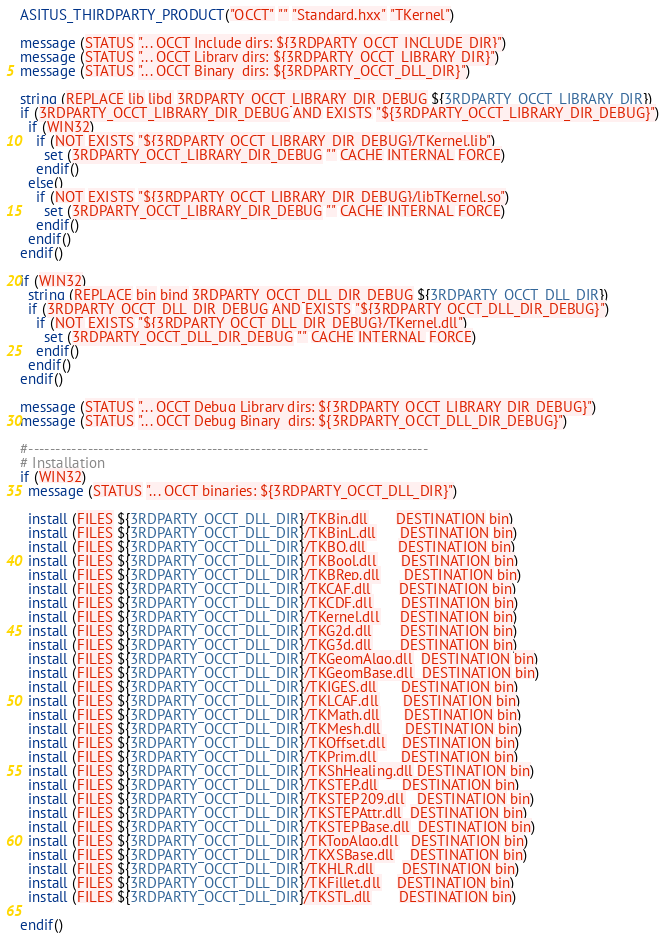<code> <loc_0><loc_0><loc_500><loc_500><_CMake_>ASITUS_THIRDPARTY_PRODUCT("OCCT" "" "Standard.hxx" "TKernel")

message (STATUS "... OCCT Include dirs: ${3RDPARTY_OCCT_INCLUDE_DIR}")
message (STATUS "... OCCT Library dirs: ${3RDPARTY_OCCT_LIBRARY_DIR}")
message (STATUS "... OCCT Binary  dirs: ${3RDPARTY_OCCT_DLL_DIR}")

string (REPLACE lib libd 3RDPARTY_OCCT_LIBRARY_DIR_DEBUG ${3RDPARTY_OCCT_LIBRARY_DIR})
if (3RDPARTY_OCCT_LIBRARY_DIR_DEBUG AND EXISTS "${3RDPARTY_OCCT_LIBRARY_DIR_DEBUG}")
  if (WIN32)
    if (NOT EXISTS "${3RDPARTY_OCCT_LIBRARY_DIR_DEBUG}/TKernel.lib")
      set (3RDPARTY_OCCT_LIBRARY_DIR_DEBUG "" CACHE INTERNAL FORCE)
    endif()
  else()
    if (NOT EXISTS "${3RDPARTY_OCCT_LIBRARY_DIR_DEBUG}/libTKernel.so")
      set (3RDPARTY_OCCT_LIBRARY_DIR_DEBUG "" CACHE INTERNAL FORCE)
    endif()
  endif()
endif()

if (WIN32)
  string (REPLACE bin bind 3RDPARTY_OCCT_DLL_DIR_DEBUG ${3RDPARTY_OCCT_DLL_DIR})
  if (3RDPARTY_OCCT_DLL_DIR_DEBUG AND EXISTS "${3RDPARTY_OCCT_DLL_DIR_DEBUG}")
    if (NOT EXISTS "${3RDPARTY_OCCT_DLL_DIR_DEBUG}/TKernel.dll")
      set (3RDPARTY_OCCT_DLL_DIR_DEBUG "" CACHE INTERNAL FORCE)
    endif()
  endif()
endif()

message (STATUS "... OCCT Debug Library dirs: ${3RDPARTY_OCCT_LIBRARY_DIR_DEBUG}")
message (STATUS "... OCCT Debug Binary  dirs: ${3RDPARTY_OCCT_DLL_DIR_DEBUG}")

#--------------------------------------------------------------------------
# Installation
if (WIN32)
  message (STATUS "... OCCT binaries: ${3RDPARTY_OCCT_DLL_DIR}")

  install (FILES ${3RDPARTY_OCCT_DLL_DIR}/TKBin.dll       DESTINATION bin)
  install (FILES ${3RDPARTY_OCCT_DLL_DIR}/TKBinL.dll      DESTINATION bin)
  install (FILES ${3RDPARTY_OCCT_DLL_DIR}/TKBO.dll        DESTINATION bin)
  install (FILES ${3RDPARTY_OCCT_DLL_DIR}/TKBool.dll      DESTINATION bin)
  install (FILES ${3RDPARTY_OCCT_DLL_DIR}/TKBRep.dll      DESTINATION bin)
  install (FILES ${3RDPARTY_OCCT_DLL_DIR}/TKCAF.dll       DESTINATION bin)
  install (FILES ${3RDPARTY_OCCT_DLL_DIR}/TKCDF.dll       DESTINATION bin)
  install (FILES ${3RDPARTY_OCCT_DLL_DIR}/TKernel.dll     DESTINATION bin)
  install (FILES ${3RDPARTY_OCCT_DLL_DIR}/TKG2d.dll       DESTINATION bin)
  install (FILES ${3RDPARTY_OCCT_DLL_DIR}/TKG3d.dll       DESTINATION bin)
  install (FILES ${3RDPARTY_OCCT_DLL_DIR}/TKGeomAlgo.dll  DESTINATION bin)
  install (FILES ${3RDPARTY_OCCT_DLL_DIR}/TKGeomBase.dll  DESTINATION bin)
  install (FILES ${3RDPARTY_OCCT_DLL_DIR}/TKIGES.dll      DESTINATION bin)
  install (FILES ${3RDPARTY_OCCT_DLL_DIR}/TKLCAF.dll      DESTINATION bin)
  install (FILES ${3RDPARTY_OCCT_DLL_DIR}/TKMath.dll      DESTINATION bin)
  install (FILES ${3RDPARTY_OCCT_DLL_DIR}/TKMesh.dll      DESTINATION bin)
  install (FILES ${3RDPARTY_OCCT_DLL_DIR}/TKOffset.dll    DESTINATION bin)
  install (FILES ${3RDPARTY_OCCT_DLL_DIR}/TKPrim.dll      DESTINATION bin)
  install (FILES ${3RDPARTY_OCCT_DLL_DIR}/TKShHealing.dll DESTINATION bin)
  install (FILES ${3RDPARTY_OCCT_DLL_DIR}/TKSTEP.dll      DESTINATION bin)
  install (FILES ${3RDPARTY_OCCT_DLL_DIR}/TKSTEP209.dll   DESTINATION bin)
  install (FILES ${3RDPARTY_OCCT_DLL_DIR}/TKSTEPAttr.dll  DESTINATION bin)
  install (FILES ${3RDPARTY_OCCT_DLL_DIR}/TKSTEPBase.dll  DESTINATION bin)
  install (FILES ${3RDPARTY_OCCT_DLL_DIR}/TKTopAlgo.dll   DESTINATION bin)
  install (FILES ${3RDPARTY_OCCT_DLL_DIR}/TKXSBase.dll    DESTINATION bin)
  install (FILES ${3RDPARTY_OCCT_DLL_DIR}/TKHLR.dll       DESTINATION bin)
  install (FILES ${3RDPARTY_OCCT_DLL_DIR}/TKFillet.dll    DESTINATION bin)
  install (FILES ${3RDPARTY_OCCT_DLL_DIR}/TKSTL.dll       DESTINATION bin)

endif()
</code> 